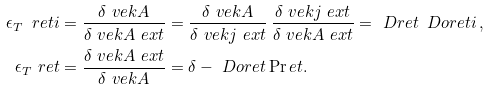<formula> <loc_0><loc_0><loc_500><loc_500>\epsilon _ { T } \ r e t i & = \frac { \delta \ v e k { A } } { \delta \ v e k { A } \ e x t } = \frac { \delta \ v e k { A } } { \delta \ v e k { j } \ e x t } \, \frac { \delta \ v e k { j } \ e x t } { \delta \ v e k { A } \ e x t } = \ D r e t \, \ D o r e t i \, , \\ \epsilon _ { T } \ r e t & = \frac { \delta \ v e k { A } \ e x t } { \delta \ v e k { A } } = \delta - \ D o r e t \Pr e t .</formula> 